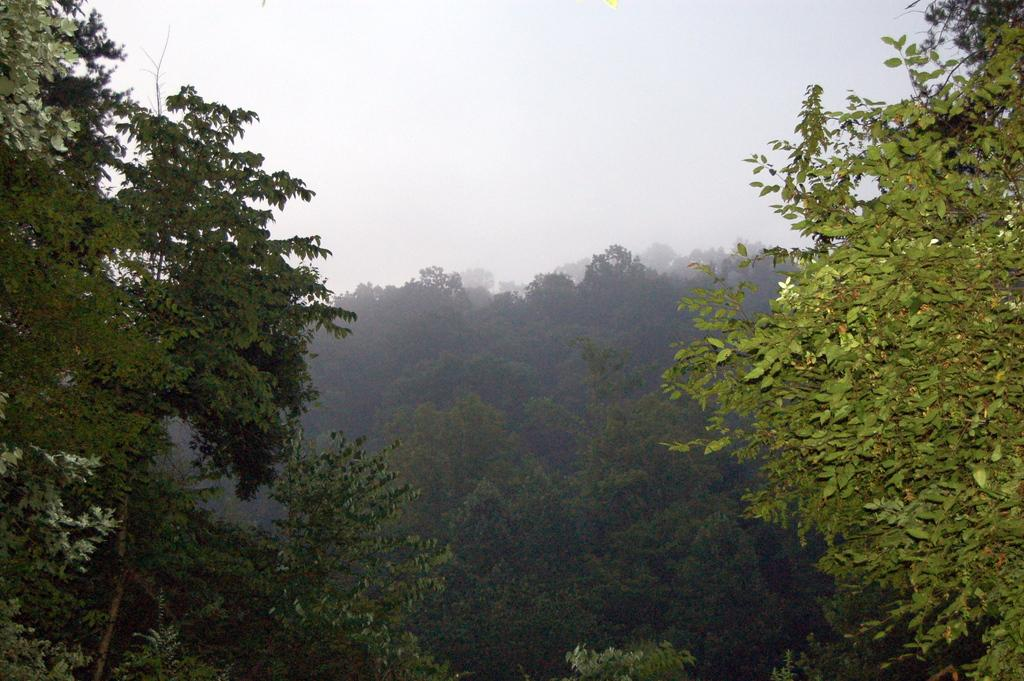What type of vegetation can be seen in the image? There are trees in the image. What part of the natural environment is visible in the image? The sky is visible in the background of the image. How many jellyfish can be seen swimming in the image? There are no jellyfish present in the image; it features trees and the sky. What type of coat is the rat wearing in the image? There is no rat present in the image, and therefore no coat can be observed. 